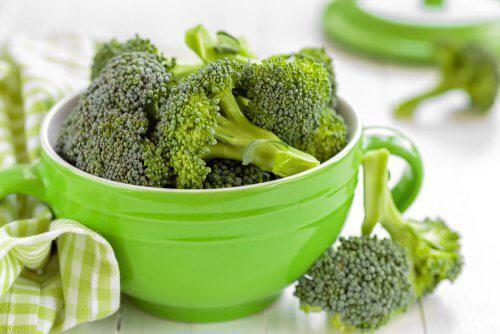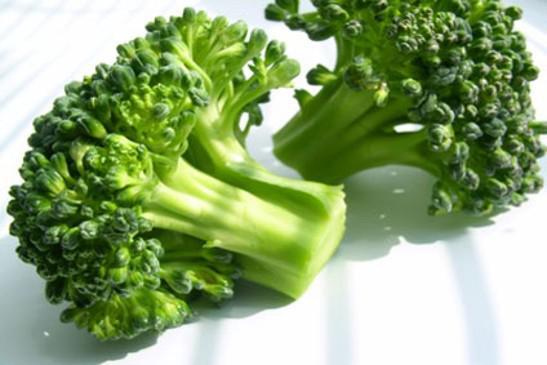The first image is the image on the left, the second image is the image on the right. Considering the images on both sides, is "There is exactly one bowl of broccoli." valid? Answer yes or no. Yes. The first image is the image on the left, the second image is the image on the right. Analyze the images presented: Is the assertion "A bowl of just broccoli sits on a table with some broccoli pieces around it." valid? Answer yes or no. Yes. 